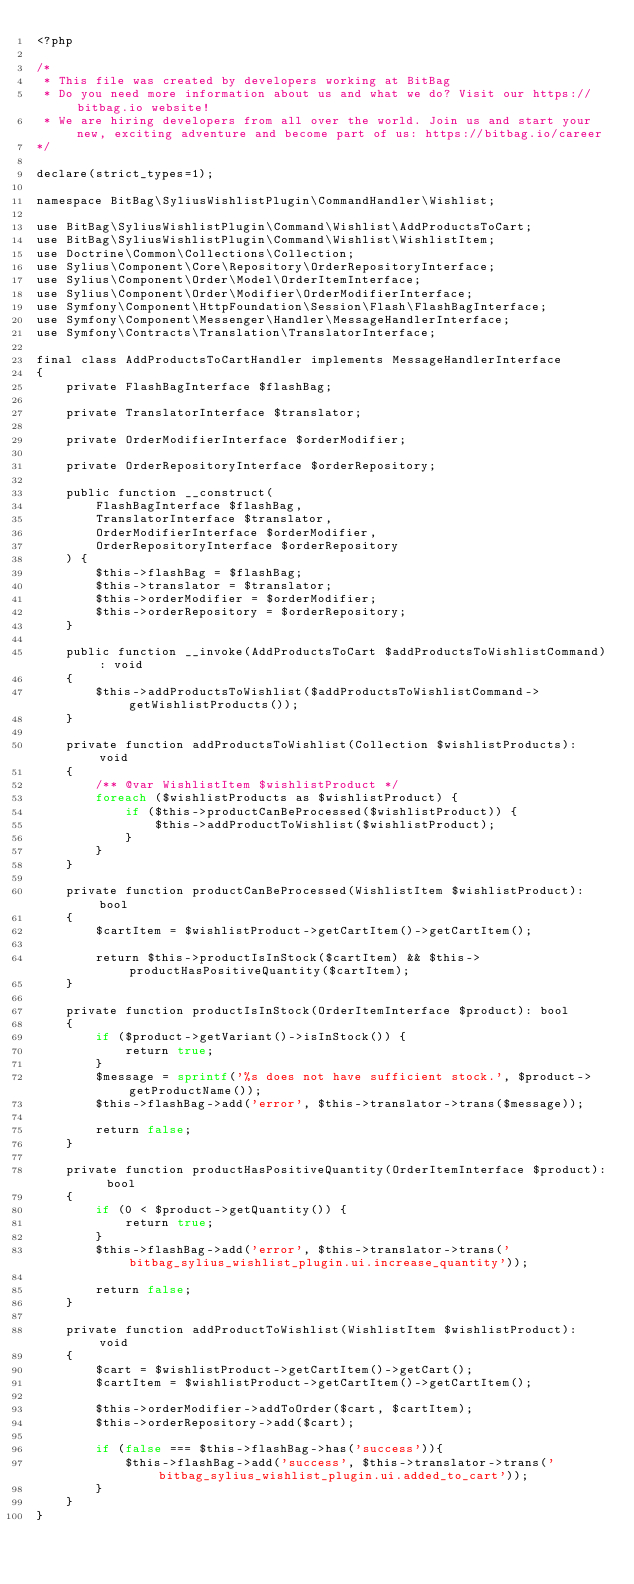<code> <loc_0><loc_0><loc_500><loc_500><_PHP_><?php

/*
 * This file was created by developers working at BitBag
 * Do you need more information about us and what we do? Visit our https://bitbag.io website!
 * We are hiring developers from all over the world. Join us and start your new, exciting adventure and become part of us: https://bitbag.io/career
*/

declare(strict_types=1);

namespace BitBag\SyliusWishlistPlugin\CommandHandler\Wishlist;

use BitBag\SyliusWishlistPlugin\Command\Wishlist\AddProductsToCart;
use BitBag\SyliusWishlistPlugin\Command\Wishlist\WishlistItem;
use Doctrine\Common\Collections\Collection;
use Sylius\Component\Core\Repository\OrderRepositoryInterface;
use Sylius\Component\Order\Model\OrderItemInterface;
use Sylius\Component\Order\Modifier\OrderModifierInterface;
use Symfony\Component\HttpFoundation\Session\Flash\FlashBagInterface;
use Symfony\Component\Messenger\Handler\MessageHandlerInterface;
use Symfony\Contracts\Translation\TranslatorInterface;

final class AddProductsToCartHandler implements MessageHandlerInterface
{
    private FlashBagInterface $flashBag;

    private TranslatorInterface $translator;

    private OrderModifierInterface $orderModifier;

    private OrderRepositoryInterface $orderRepository;

    public function __construct(
        FlashBagInterface $flashBag,
        TranslatorInterface $translator,
        OrderModifierInterface $orderModifier,
        OrderRepositoryInterface $orderRepository
    ) {
        $this->flashBag = $flashBag;
        $this->translator = $translator;
        $this->orderModifier = $orderModifier;
        $this->orderRepository = $orderRepository;
    }

    public function __invoke(AddProductsToCart $addProductsToWishlistCommand): void
    {
        $this->addProductsToWishlist($addProductsToWishlistCommand->getWishlistProducts());
    }

    private function addProductsToWishlist(Collection $wishlistProducts): void
    {
        /** @var WishlistItem $wishlistProduct */
        foreach ($wishlistProducts as $wishlistProduct) {
            if ($this->productCanBeProcessed($wishlistProduct)) {
                $this->addProductToWishlist($wishlistProduct);
            }
        }
    }

    private function productCanBeProcessed(WishlistItem $wishlistProduct): bool
    {
        $cartItem = $wishlistProduct->getCartItem()->getCartItem();

        return $this->productIsInStock($cartItem) && $this->productHasPositiveQuantity($cartItem);
    }

    private function productIsInStock(OrderItemInterface $product): bool
    {
        if ($product->getVariant()->isInStock()) {
            return true;
        }
        $message = sprintf('%s does not have sufficient stock.', $product->getProductName());
        $this->flashBag->add('error', $this->translator->trans($message));

        return false;
    }

    private function productHasPositiveQuantity(OrderItemInterface $product): bool
    {
        if (0 < $product->getQuantity()) {
            return true;
        }
        $this->flashBag->add('error', $this->translator->trans('bitbag_sylius_wishlist_plugin.ui.increase_quantity'));

        return false;
    }

    private function addProductToWishlist(WishlistItem $wishlistProduct): void
    {
        $cart = $wishlistProduct->getCartItem()->getCart();
        $cartItem = $wishlistProduct->getCartItem()->getCartItem();

        $this->orderModifier->addToOrder($cart, $cartItem);
        $this->orderRepository->add($cart);

        if (false === $this->flashBag->has('success')){
            $this->flashBag->add('success', $this->translator->trans('bitbag_sylius_wishlist_plugin.ui.added_to_cart'));
        }
    }
}
</code> 